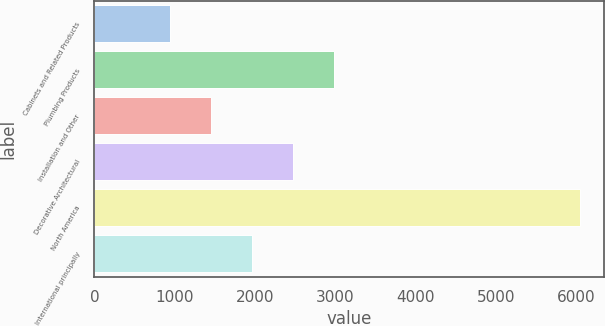Convert chart. <chart><loc_0><loc_0><loc_500><loc_500><bar_chart><fcel>Cabinets and Related Products<fcel>Plumbing Products<fcel>Installation and Other<fcel>Decorative Architectural<fcel>North America<fcel>International principally<nl><fcel>939<fcel>2981.8<fcel>1449.7<fcel>2471.1<fcel>6046<fcel>1960.4<nl></chart> 